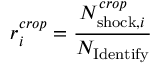Convert formula to latex. <formula><loc_0><loc_0><loc_500><loc_500>r _ { i } ^ { c r o p } = \frac { N _ { { s h o c k } , i } ^ { c r o p } } { N _ { I d e n t i f y } }</formula> 